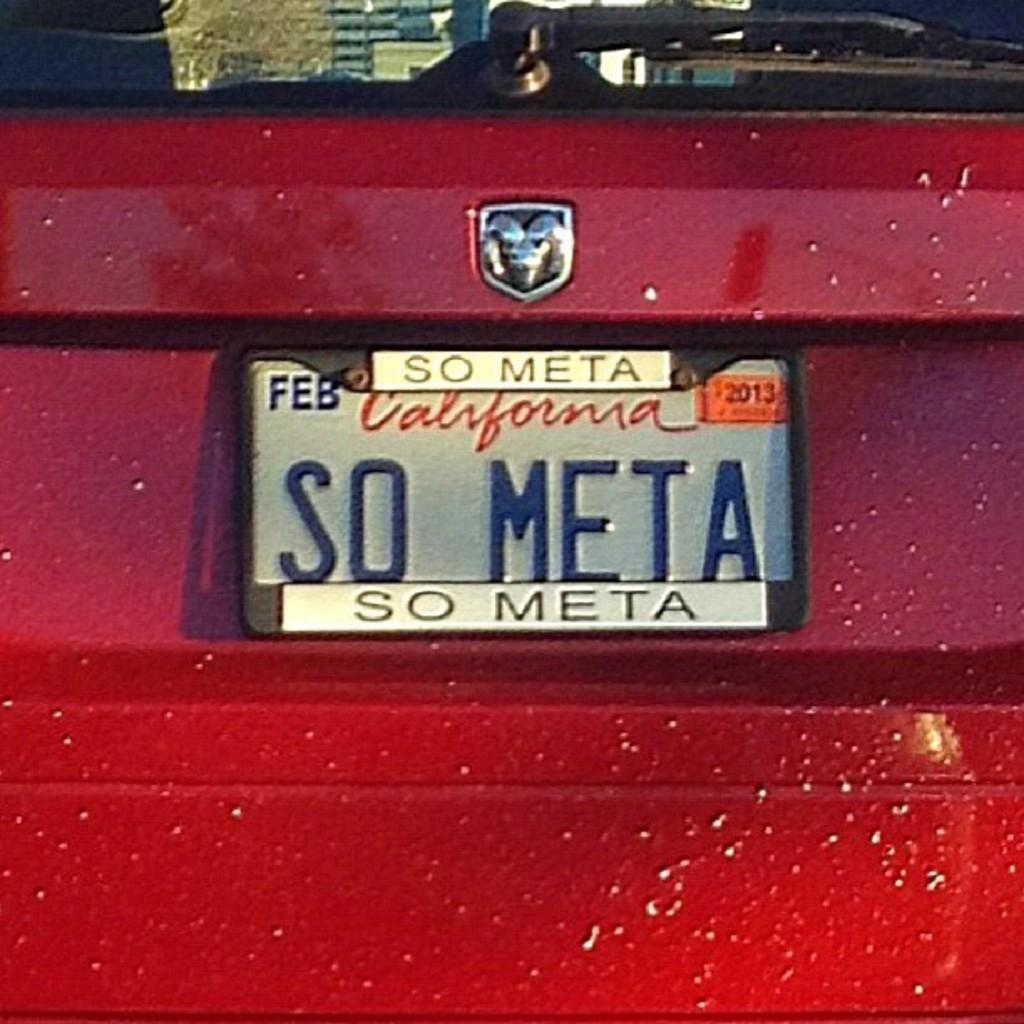<image>
Describe the image concisely. Red California license plate which says "So Meta" on it. 